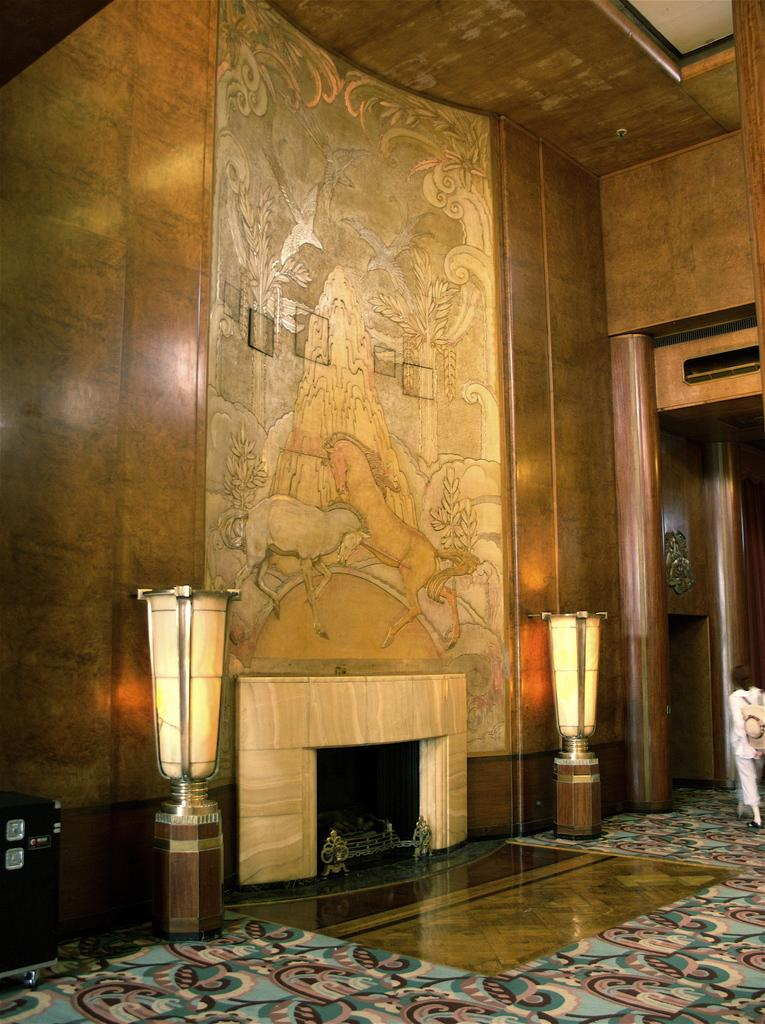What can be seen on the wall in the image? There is a wall with a design in the image. What feature is present near the wall in the image? There is a hearth in the image. How many corks are placed on the hearth in the image? There is no mention of corks in the image, so it is impossible to determine their presence or quantity. Are there any women interacting with the hearth in the image? There is no information about women or their interactions with the hearth in the image. 